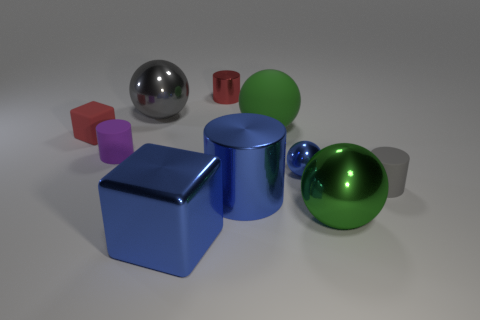How many objects are cylinders that are left of the large blue metallic block or cyan metallic objects?
Provide a short and direct response. 1. There is a red object that is on the right side of the red cube; what is its size?
Your response must be concise. Small. What is the material of the purple cylinder?
Offer a terse response. Rubber. There is a green thing behind the big sphere that is in front of the small red matte thing; what is its shape?
Ensure brevity in your answer.  Sphere. What number of other objects are the same shape as the gray rubber thing?
Give a very brief answer. 3. Are there any cubes behind the gray sphere?
Provide a short and direct response. No. The small cube is what color?
Provide a succinct answer. Red. There is a big rubber ball; is it the same color as the metallic cylinder that is behind the tiny gray matte cylinder?
Offer a terse response. No. Are there any blue balls of the same size as the gray rubber cylinder?
Offer a terse response. Yes. What size is the shiny object that is the same color as the big rubber object?
Offer a terse response. Large. 